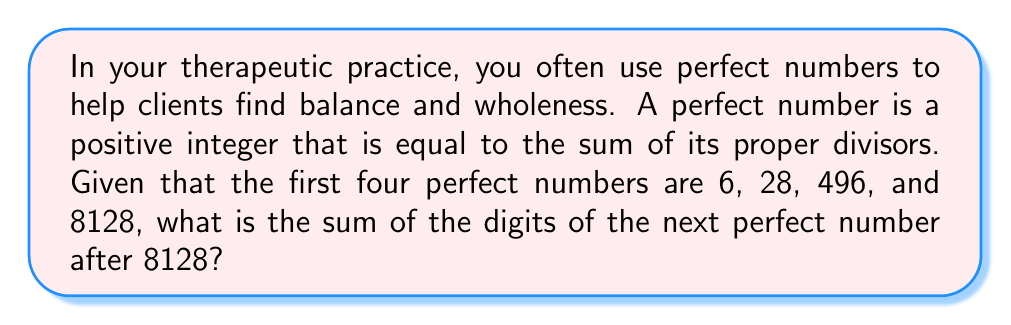Can you solve this math problem? Let's approach this step-by-step:

1) First, we need to find the next perfect number after 8128.

2) The formula for even perfect numbers is:

   $$ 2^{n-1}(2^n - 1) $$

   where $2^n - 1$ is prime.

3) For the first four perfect numbers:
   - When $n = 2$: $2^1(2^2 - 1) = 2 \times 3 = 6$
   - When $n = 3$: $2^2(2^3 - 1) = 4 \times 7 = 28$
   - When $n = 5$: $2^4(2^5 - 1) = 16 \times 31 = 496$
   - When $n = 7$: $2^6(2^7 - 1) = 64 \times 127 = 8128$

4) The next perfect number will be when $n = 13$, as $2^{13} - 1 = 8191$ is prime.

5) So, the next perfect number is:

   $$ 2^{12}(2^{13} - 1) = 4096 \times 8191 = 33,550,336 $$

6) Now, we need to sum the digits of 33,550,336:

   $3 + 3 + 5 + 5 + 0 + 3 + 3 + 6 = 28$

Therefore, the sum of the digits of the next perfect number after 8128 is 28.
Answer: 28 